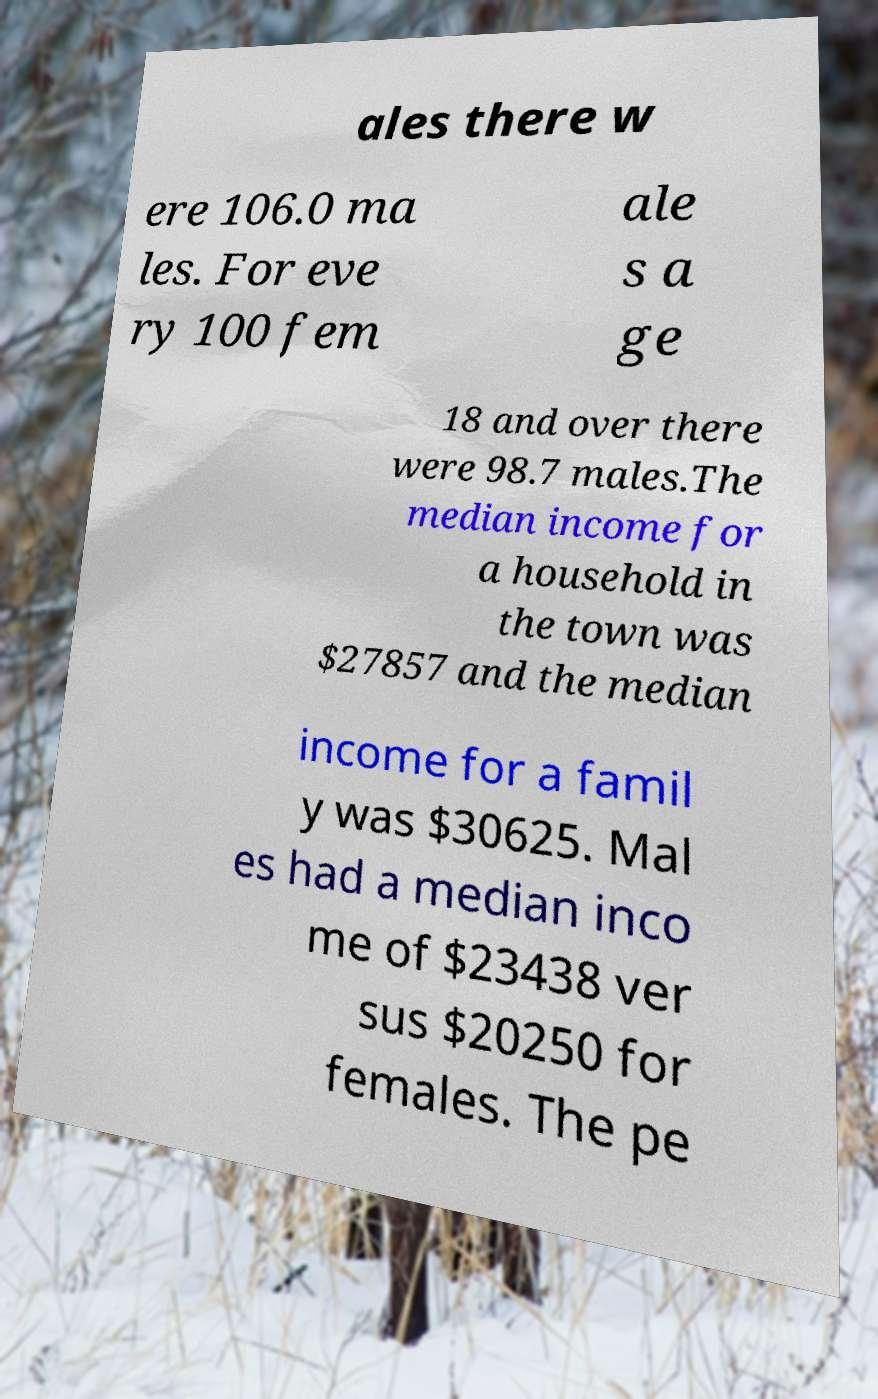For documentation purposes, I need the text within this image transcribed. Could you provide that? ales there w ere 106.0 ma les. For eve ry 100 fem ale s a ge 18 and over there were 98.7 males.The median income for a household in the town was $27857 and the median income for a famil y was $30625. Mal es had a median inco me of $23438 ver sus $20250 for females. The pe 